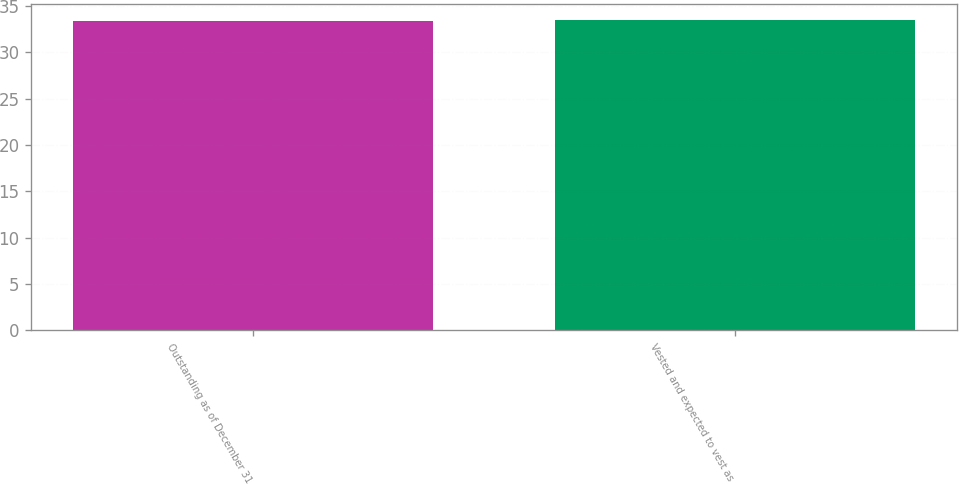<chart> <loc_0><loc_0><loc_500><loc_500><bar_chart><fcel>Outstanding as of December 31<fcel>Vested and expected to vest as<nl><fcel>33.41<fcel>33.51<nl></chart> 